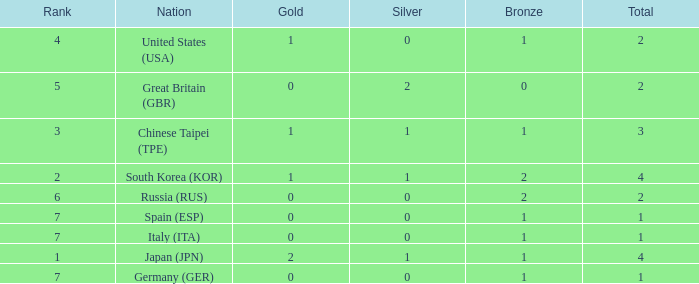How many total medals does a country with more than 1 silver medals have? 2.0. 